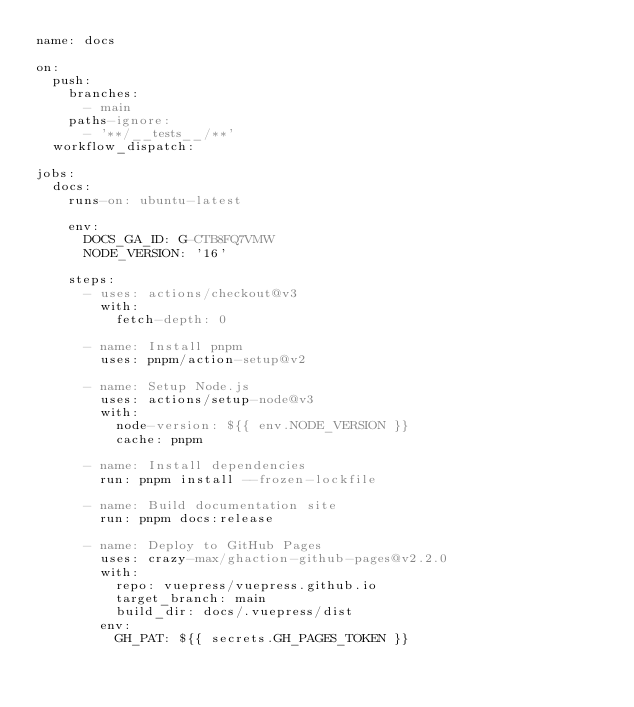<code> <loc_0><loc_0><loc_500><loc_500><_YAML_>name: docs

on:
  push:
    branches:
      - main
    paths-ignore:
      - '**/__tests__/**'
  workflow_dispatch:

jobs:
  docs:
    runs-on: ubuntu-latest

    env:
      DOCS_GA_ID: G-CTB8FQ7VMW
      NODE_VERSION: '16'

    steps:
      - uses: actions/checkout@v3
        with:
          fetch-depth: 0

      - name: Install pnpm
        uses: pnpm/action-setup@v2

      - name: Setup Node.js
        uses: actions/setup-node@v3
        with:
          node-version: ${{ env.NODE_VERSION }}
          cache: pnpm

      - name: Install dependencies
        run: pnpm install --frozen-lockfile

      - name: Build documentation site
        run: pnpm docs:release

      - name: Deploy to GitHub Pages
        uses: crazy-max/ghaction-github-pages@v2.2.0
        with:
          repo: vuepress/vuepress.github.io
          target_branch: main
          build_dir: docs/.vuepress/dist
        env:
          GH_PAT: ${{ secrets.GH_PAGES_TOKEN }}
</code> 